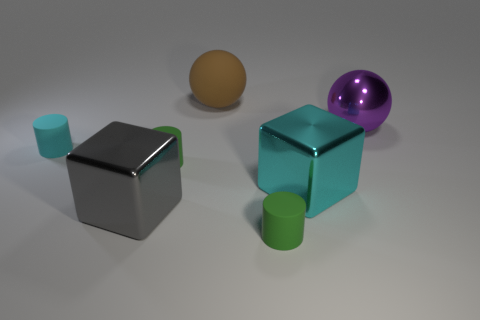The brown matte object that is the same shape as the purple shiny object is what size?
Give a very brief answer. Large. There is a cylinder that is on the left side of the rubber sphere and on the right side of the cyan rubber thing; what size is it?
Your answer should be very brief. Small. There is a big gray thing; are there any large gray cubes left of it?
Give a very brief answer. No. How many objects are either things that are in front of the big purple metallic thing or blue rubber cubes?
Offer a terse response. 5. What number of tiny things are to the left of the green rubber cylinder right of the large brown rubber thing?
Your answer should be very brief. 2. Is the number of brown matte things that are on the right side of the large cyan metal cube less than the number of purple objects that are on the left side of the matte ball?
Provide a short and direct response. No. There is a cyan metallic thing that is right of the matte thing that is behind the cyan matte cylinder; what is its shape?
Give a very brief answer. Cube. What number of other things are the same material as the big cyan thing?
Your answer should be very brief. 2. Are there any other things that are the same size as the cyan matte cylinder?
Your answer should be compact. Yes. Is the number of cyan metal blocks greater than the number of tiny objects?
Your response must be concise. No. 